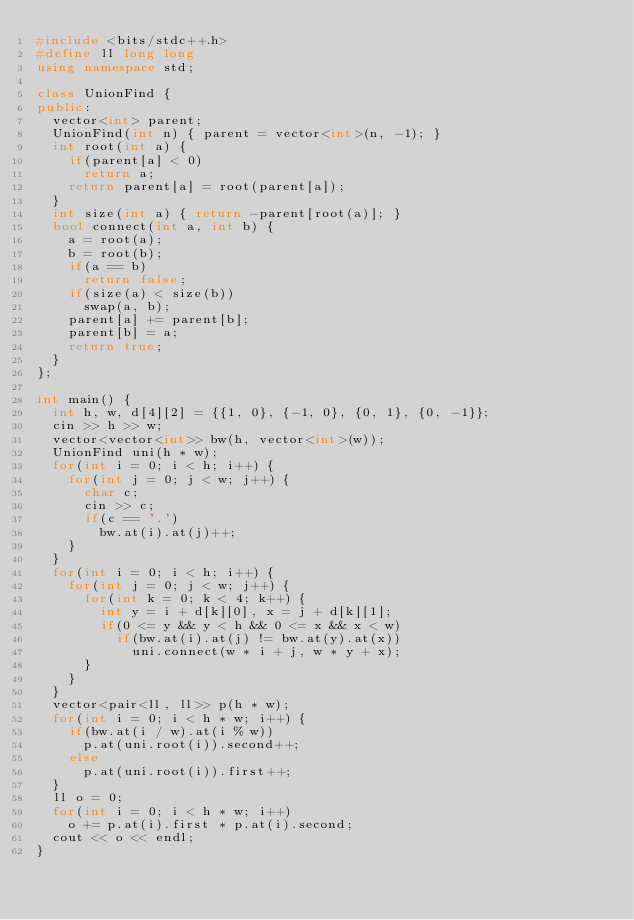<code> <loc_0><loc_0><loc_500><loc_500><_C++_>#include <bits/stdc++.h>
#define ll long long
using namespace std;

class UnionFind {
public:
  vector<int> parent;
  UnionFind(int n) { parent = vector<int>(n, -1); }
  int root(int a) {
    if(parent[a] < 0)
      return a;
    return parent[a] = root(parent[a]);
  }
  int size(int a) { return -parent[root(a)]; }
  bool connect(int a, int b) {
    a = root(a);
    b = root(b);
    if(a == b)
      return false;
    if(size(a) < size(b))
      swap(a, b);
    parent[a] += parent[b];
    parent[b] = a;
    return true;
  }
};

int main() {
  int h, w, d[4][2] = {{1, 0}, {-1, 0}, {0, 1}, {0, -1}};
  cin >> h >> w;
  vector<vector<int>> bw(h, vector<int>(w));
  UnionFind uni(h * w);
  for(int i = 0; i < h; i++) {
    for(int j = 0; j < w; j++) {
      char c;
      cin >> c;
      if(c == '.')
        bw.at(i).at(j)++;
    }
  }
  for(int i = 0; i < h; i++) {
    for(int j = 0; j < w; j++) {
      for(int k = 0; k < 4; k++) {
        int y = i + d[k][0], x = j + d[k][1];
        if(0 <= y && y < h && 0 <= x && x < w)
          if(bw.at(i).at(j) != bw.at(y).at(x))
            uni.connect(w * i + j, w * y + x);
      }
    }
  }
  vector<pair<ll, ll>> p(h * w);
  for(int i = 0; i < h * w; i++) {
    if(bw.at(i / w).at(i % w))
      p.at(uni.root(i)).second++;
    else
      p.at(uni.root(i)).first++;
  }
  ll o = 0;
  for(int i = 0; i < h * w; i++)
    o += p.at(i).first * p.at(i).second;
  cout << o << endl;
}</code> 